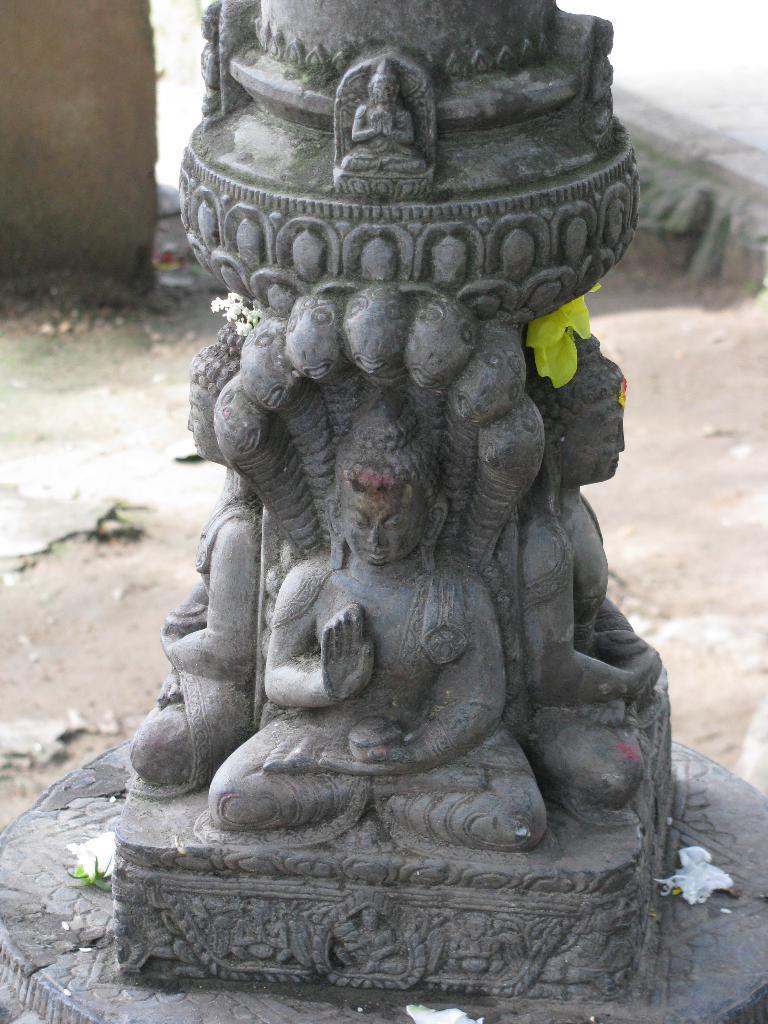How would you summarize this image in a sentence or two? In this image I can see pillar and god statues on it. It is in grey color. We can see yellow and white color flower. 